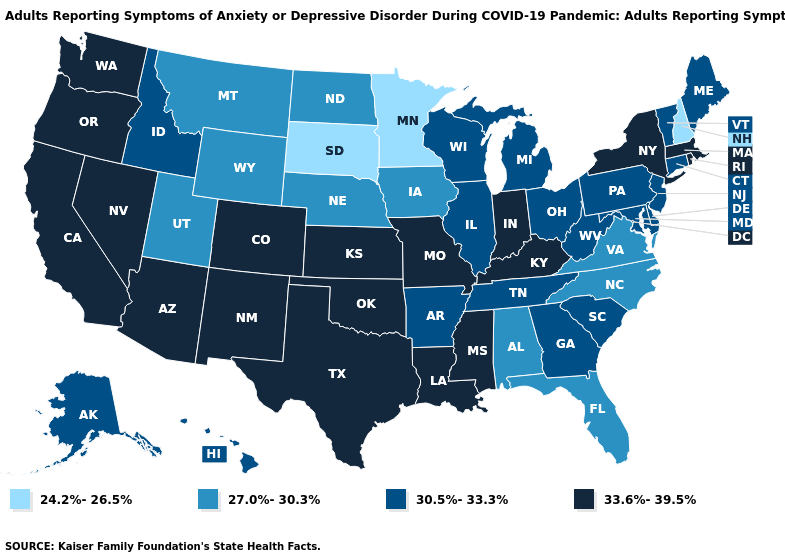What is the value of Utah?
Short answer required. 27.0%-30.3%. Does the first symbol in the legend represent the smallest category?
Concise answer only. Yes. Does New Hampshire have the lowest value in the USA?
Short answer required. Yes. Does Tennessee have a lower value than Mississippi?
Give a very brief answer. Yes. Among the states that border Alabama , which have the highest value?
Concise answer only. Mississippi. Name the states that have a value in the range 24.2%-26.5%?
Give a very brief answer. Minnesota, New Hampshire, South Dakota. What is the lowest value in states that border New York?
Short answer required. 30.5%-33.3%. What is the value of Alaska?
Concise answer only. 30.5%-33.3%. What is the value of Michigan?
Write a very short answer. 30.5%-33.3%. What is the value of Rhode Island?
Give a very brief answer. 33.6%-39.5%. What is the value of Kentucky?
Short answer required. 33.6%-39.5%. Name the states that have a value in the range 30.5%-33.3%?
Write a very short answer. Alaska, Arkansas, Connecticut, Delaware, Georgia, Hawaii, Idaho, Illinois, Maine, Maryland, Michigan, New Jersey, Ohio, Pennsylvania, South Carolina, Tennessee, Vermont, West Virginia, Wisconsin. What is the value of Hawaii?
Be succinct. 30.5%-33.3%. Does Arkansas have a higher value than Virginia?
Give a very brief answer. Yes. How many symbols are there in the legend?
Write a very short answer. 4. 